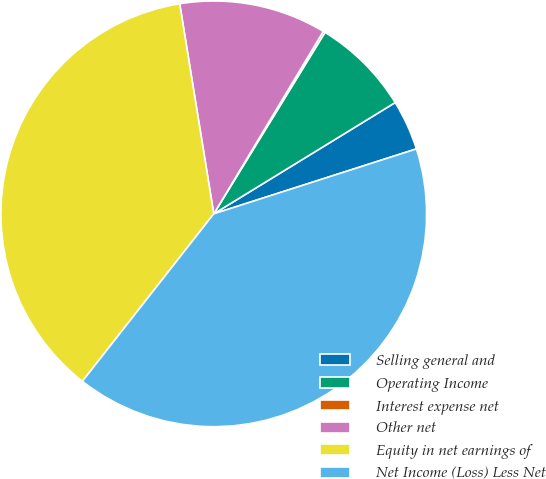Convert chart. <chart><loc_0><loc_0><loc_500><loc_500><pie_chart><fcel>Selling general and<fcel>Operating Income<fcel>Interest expense net<fcel>Other net<fcel>Equity in net earnings of<fcel>Net Income (Loss) Less Net<nl><fcel>3.82%<fcel>7.49%<fcel>0.15%<fcel>11.16%<fcel>36.85%<fcel>40.52%<nl></chart> 